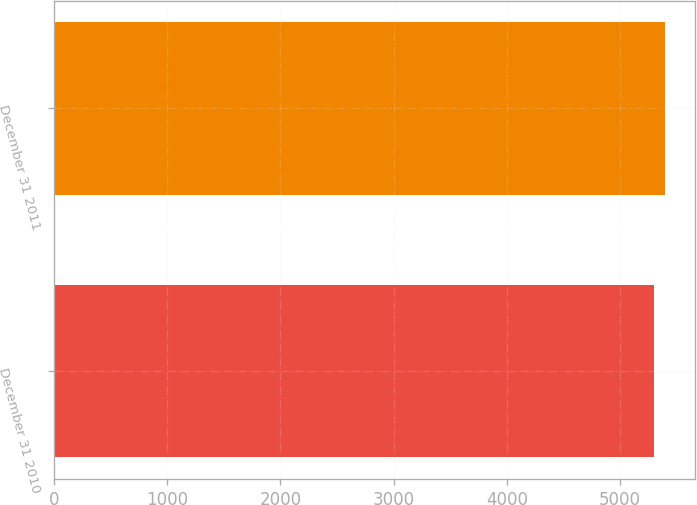Convert chart to OTSL. <chart><loc_0><loc_0><loc_500><loc_500><bar_chart><fcel>December 31 2010<fcel>December 31 2011<nl><fcel>5302<fcel>5394<nl></chart> 